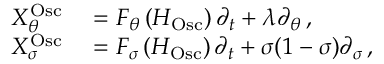<formula> <loc_0><loc_0><loc_500><loc_500>\begin{array} { r l } { X _ { \theta } ^ { O s c } } & = F _ { \theta } \left ( H _ { O s c } \right ) \partial _ { t } + \lambda \partial _ { \theta } \, , } \\ { X _ { \sigma } ^ { O s c } } & = F _ { \sigma } \left ( H _ { O s c } \right ) \partial _ { t } + \sigma ( 1 - \sigma ) \partial _ { \sigma } \, , } \end{array}</formula> 